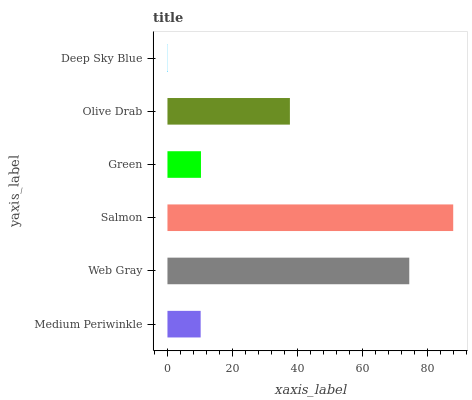Is Deep Sky Blue the minimum?
Answer yes or no. Yes. Is Salmon the maximum?
Answer yes or no. Yes. Is Web Gray the minimum?
Answer yes or no. No. Is Web Gray the maximum?
Answer yes or no. No. Is Web Gray greater than Medium Periwinkle?
Answer yes or no. Yes. Is Medium Periwinkle less than Web Gray?
Answer yes or no. Yes. Is Medium Periwinkle greater than Web Gray?
Answer yes or no. No. Is Web Gray less than Medium Periwinkle?
Answer yes or no. No. Is Olive Drab the high median?
Answer yes or no. Yes. Is Green the low median?
Answer yes or no. Yes. Is Deep Sky Blue the high median?
Answer yes or no. No. Is Medium Periwinkle the low median?
Answer yes or no. No. 